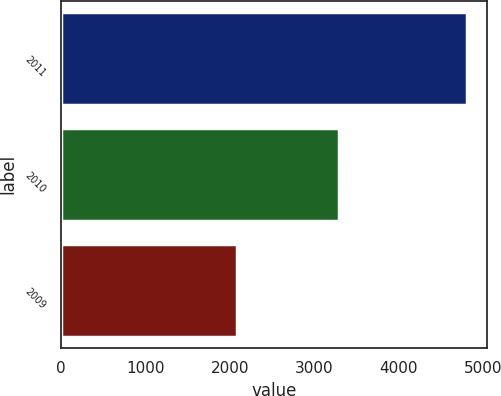<chart> <loc_0><loc_0><loc_500><loc_500><bar_chart><fcel>2011<fcel>2010<fcel>2009<nl><fcel>4806<fcel>3295<fcel>2091<nl></chart> 